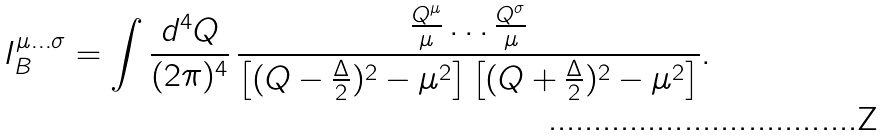<formula> <loc_0><loc_0><loc_500><loc_500>I _ { B } ^ { \mu \dots \sigma } = \int \frac { d ^ { 4 } Q } { ( 2 \pi ) ^ { 4 } } \, \frac { \frac { Q ^ { \mu } } { \mu } \dots \frac { Q ^ { \sigma } } { \mu } } { \left [ ( Q - \frac { \Delta } { 2 } ) ^ { 2 } - \mu ^ { 2 } \right ] \left [ ( Q + \frac { \Delta } { 2 } ) ^ { 2 } - \mu ^ { 2 } \right ] } .</formula> 